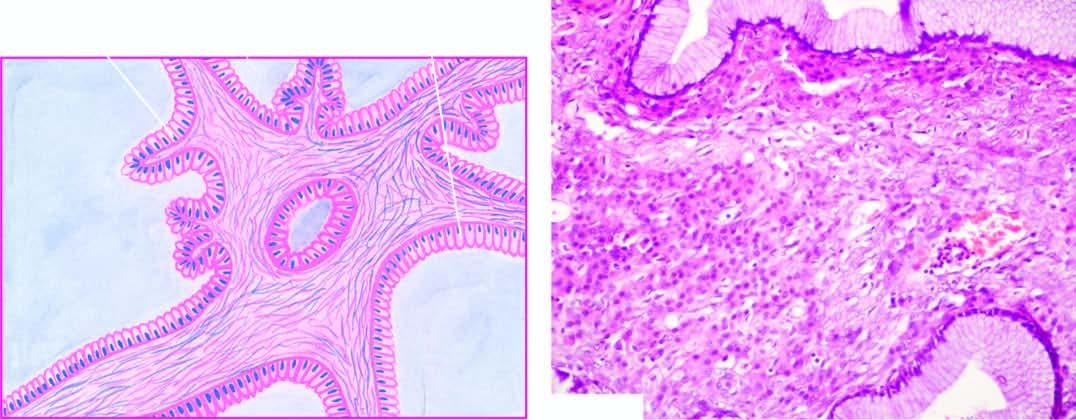what are the cyst wall and the septa lined by?
Answer the question using a single word or phrase. A single layer of tall columnar mucin-secreting epithelium with basally-placed nuclei and large apical mucinous vacuoles 